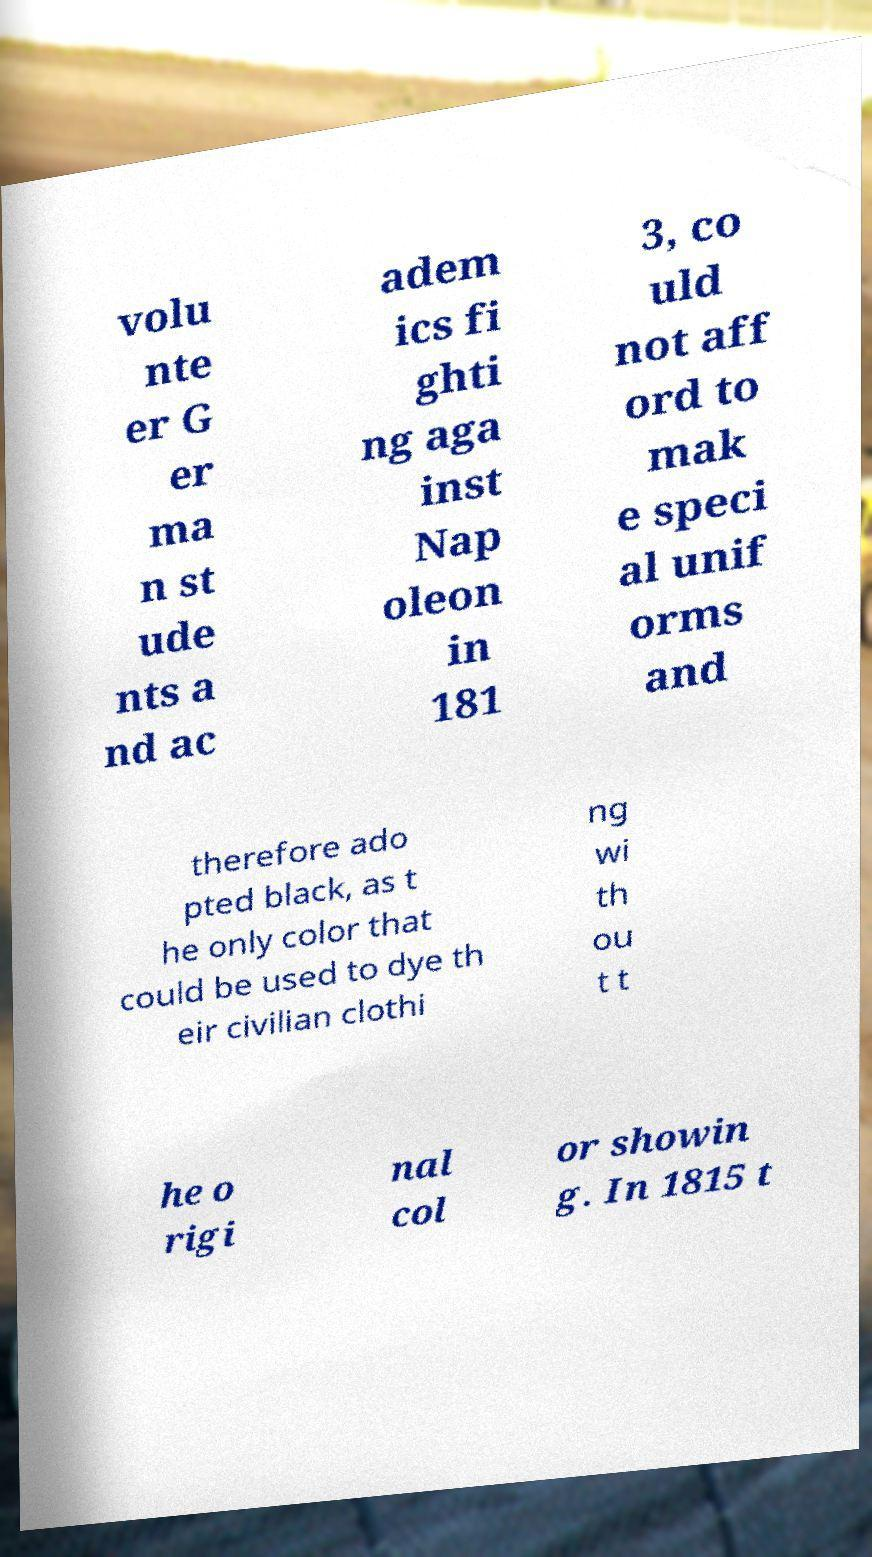Can you read and provide the text displayed in the image?This photo seems to have some interesting text. Can you extract and type it out for me? volu nte er G er ma n st ude nts a nd ac adem ics fi ghti ng aga inst Nap oleon in 181 3, co uld not aff ord to mak e speci al unif orms and therefore ado pted black, as t he only color that could be used to dye th eir civilian clothi ng wi th ou t t he o rigi nal col or showin g. In 1815 t 